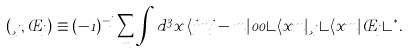<formula> <loc_0><loc_0><loc_500><loc_500>( \xi _ { j } , \phi _ { j } ) \equiv ( - 1 ) ^ { - j } \sum _ { m } \int { d ^ { 3 } x } \, \langle j m j - m | 0 0 \rangle \langle x m | \xi _ { j } \rangle \langle x m | \phi _ { j } \rangle ^ { * } .</formula> 